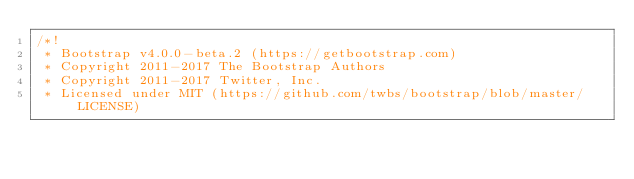Convert code to text. <code><loc_0><loc_0><loc_500><loc_500><_CSS_>/*!
 * Bootstrap v4.0.0-beta.2 (https://getbootstrap.com)
 * Copyright 2011-2017 The Bootstrap Authors
 * Copyright 2011-2017 Twitter, Inc.
 * Licensed under MIT (https://github.com/twbs/bootstrap/blob/master/LICENSE)</code> 